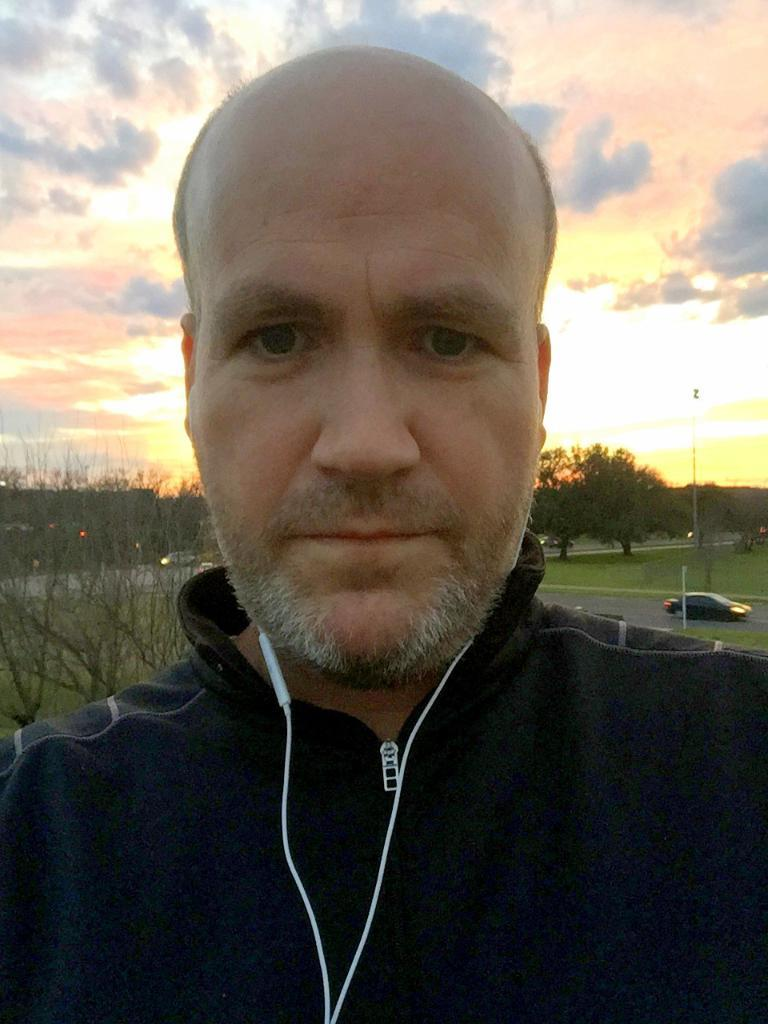What is the person in the image wearing on their ears? The person in the image is wearing headphones. What types of transportation can be seen in the image? There are vehicles in the image. What type of natural vegetation is present in the image? There are trees in the image. What are the poles on the ground used for in the image? The poles on the ground are likely used for support or signage. What is visible in the background of the image? The sky is visible in the background of the image. What type of wax can be seen dripping from the vehicles in the image? There is no wax present in the image, and no wax is dripping from the vehicles. 